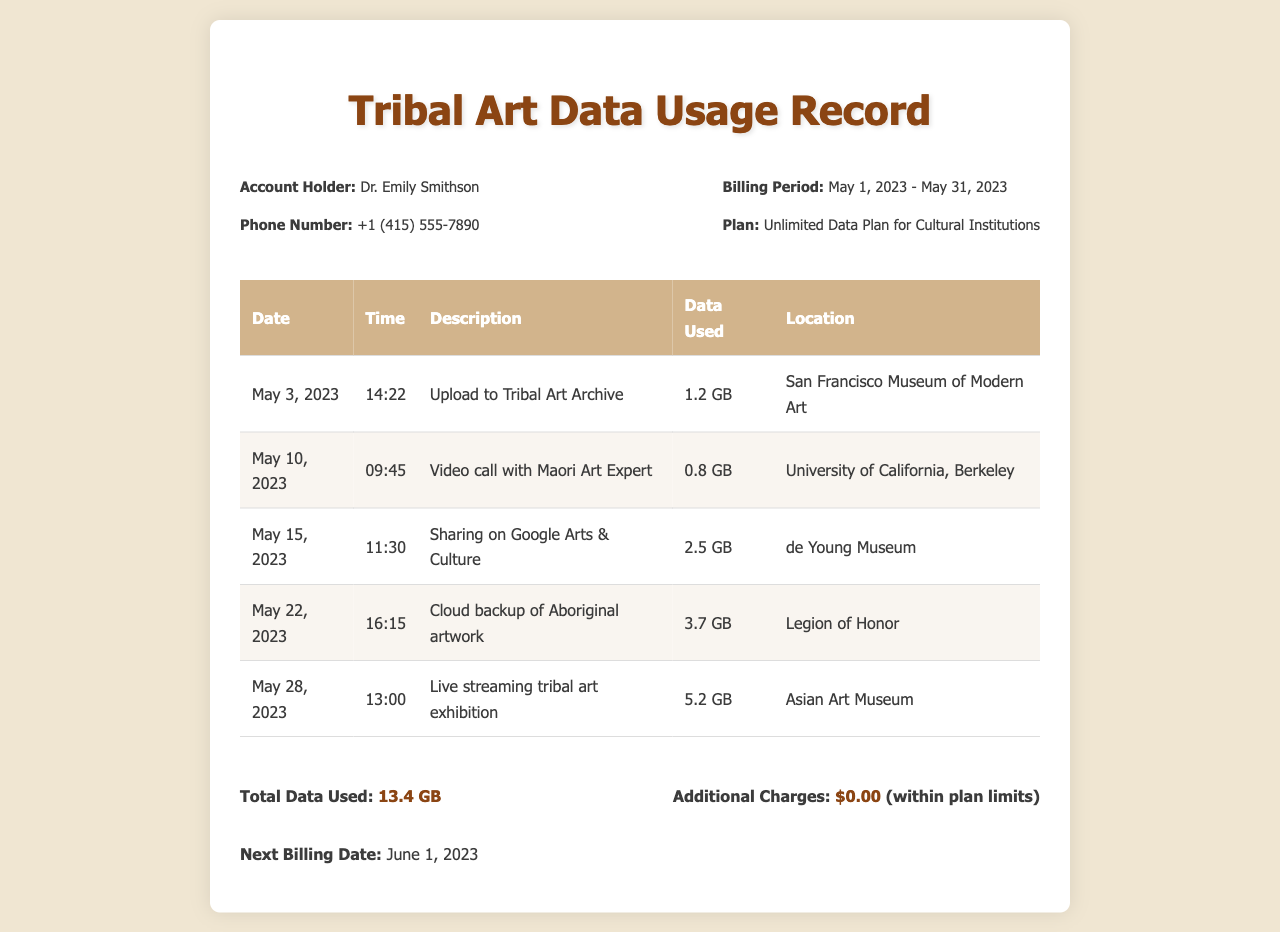What is the account holder's name? The account holder's name is explicitly stated in the document.
Answer: Dr. Emily Smithson What is the phone number listed? The document specifies the phone number of the account holder.
Answer: +1 (415) 555-7890 What was the total data used during the billing period? The total data used is summarized at the bottom of the document.
Answer: 13.4 GB What is the billing period for this record? The document clearly outlines the billing period for the account holder.
Answer: May 1, 2023 - May 31, 2023 What was the location for the upload to the Tribal Art Archive? The document indicates the location associated with the upload activity.
Answer: San Francisco Museum of Modern Art Why was the most data used on May 28, 2023? The entry indicates that the high data usage was due to live streaming.
Answer: Live streaming tribal art exhibition Which activity had the highest data usage? This can be inferred from the data used column for each activity.
Answer: Live streaming tribal art exhibition How much data was used for sharing on Google Arts & Culture? The document lists the specific data usage for this activity.
Answer: 2.5 GB What additional charges are listed for this billing period? The document states if any additional charges were incurred during this period.
Answer: $0.00 (within plan limits) 